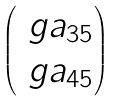<formula> <loc_0><loc_0><loc_500><loc_500>\begin{pmatrix} \ g a _ { 3 5 } \\ \ g a _ { 4 5 } \end{pmatrix}</formula> 